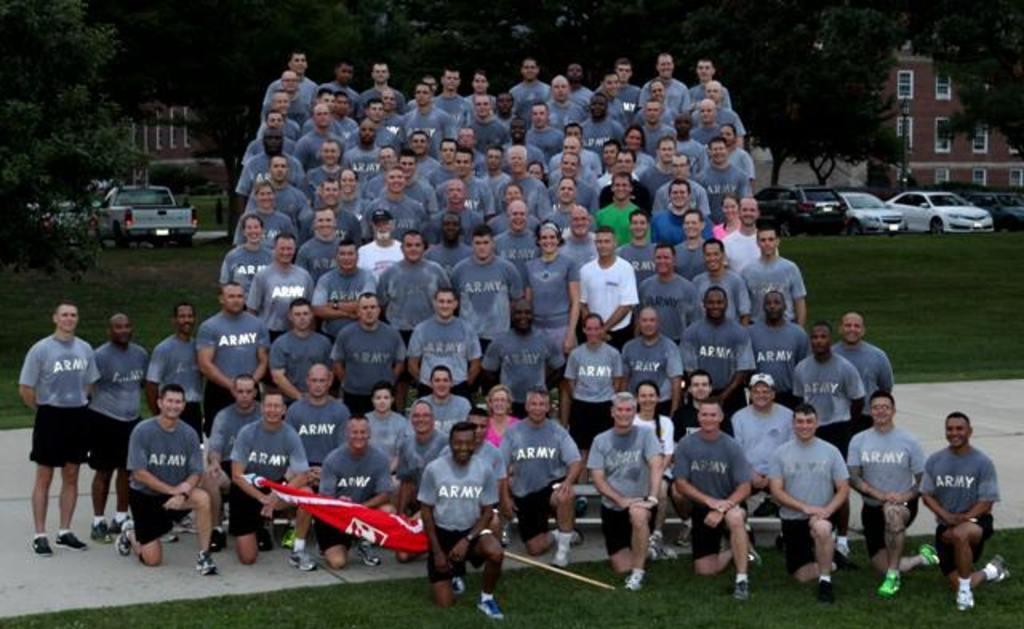In one or two sentences, can you explain what this image depicts? In the picture I can see a group of people and they are smiling. I can see a man on the bottom left side is holding a flag pole. In the background, I can see the building, cars and trees. I can see the green grass on the left side and the right side as well. 